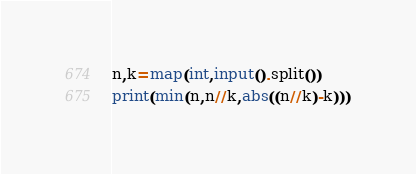<code> <loc_0><loc_0><loc_500><loc_500><_Python_>n,k=map(int,input().split())
print(min(n,n//k,abs((n//k)-k)))</code> 